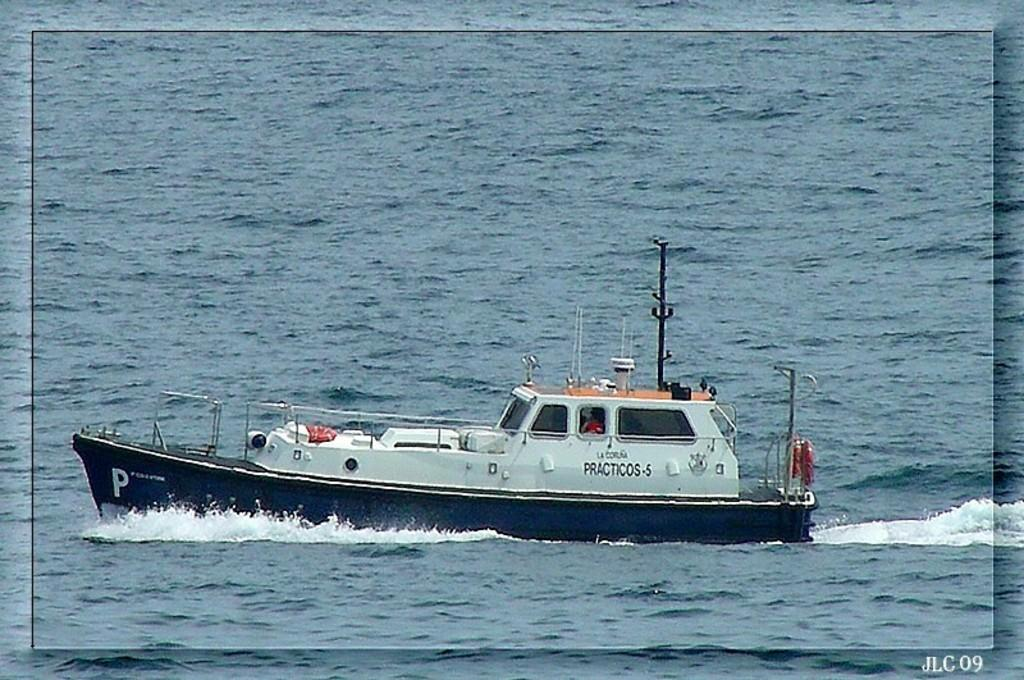What is the main subject of the image? The main subject of the image is a boat. Where is the boat located? The boat is on water. What additional items can be seen on the boat? There is a swim tube and poles on the boat. What is the belief system of the self in the image? There is no self or person present in the image, so it is not possible to determine their belief system. 